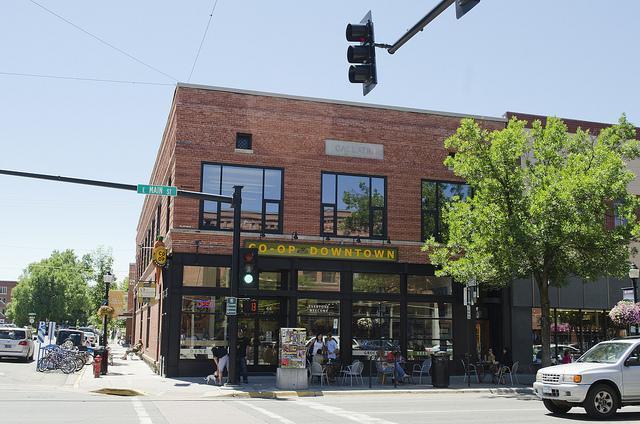How many trees are in front of the co-op?
Give a very brief answer. 1. How many traffic lights are there?
Give a very brief answer. 1. 